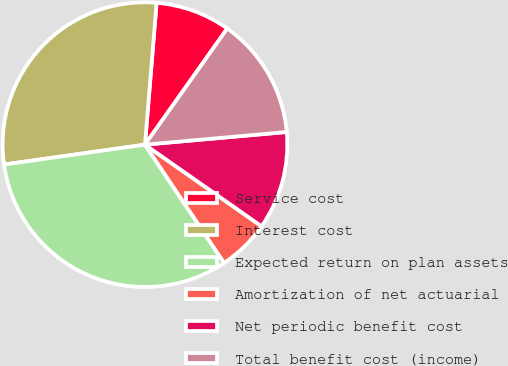<chart> <loc_0><loc_0><loc_500><loc_500><pie_chart><fcel>Service cost<fcel>Interest cost<fcel>Expected return on plan assets<fcel>Amortization of net actuarial<fcel>Net periodic benefit cost<fcel>Total benefit cost (income)<nl><fcel>8.51%<fcel>28.53%<fcel>32.16%<fcel>5.89%<fcel>11.14%<fcel>13.77%<nl></chart> 